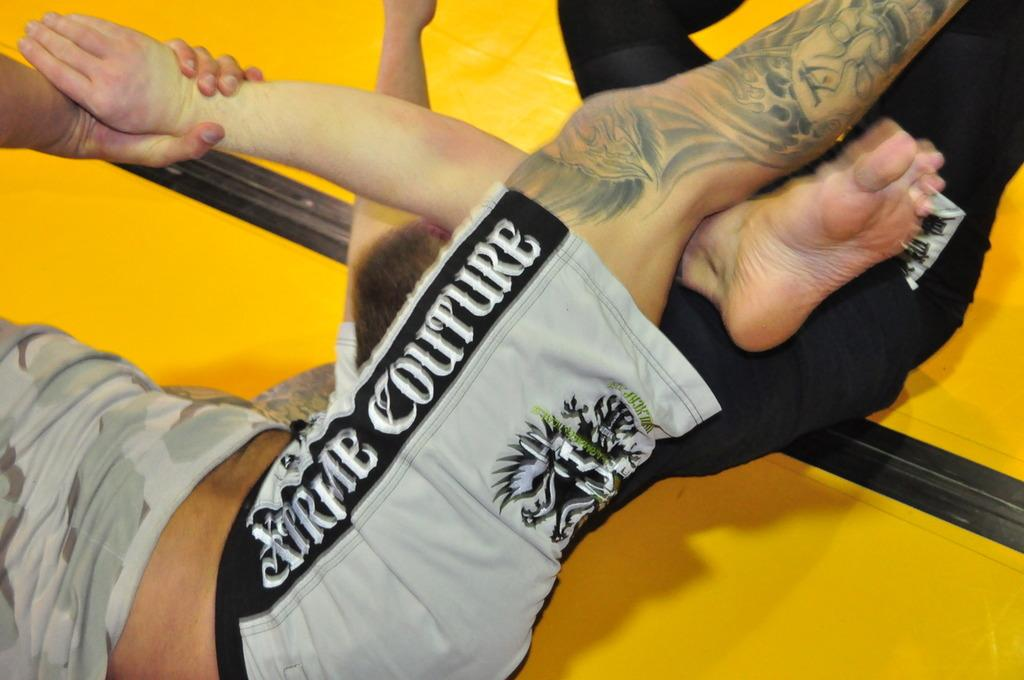<image>
Create a compact narrative representing the image presented. A pair of shorts that say Extrme Couture on them. 